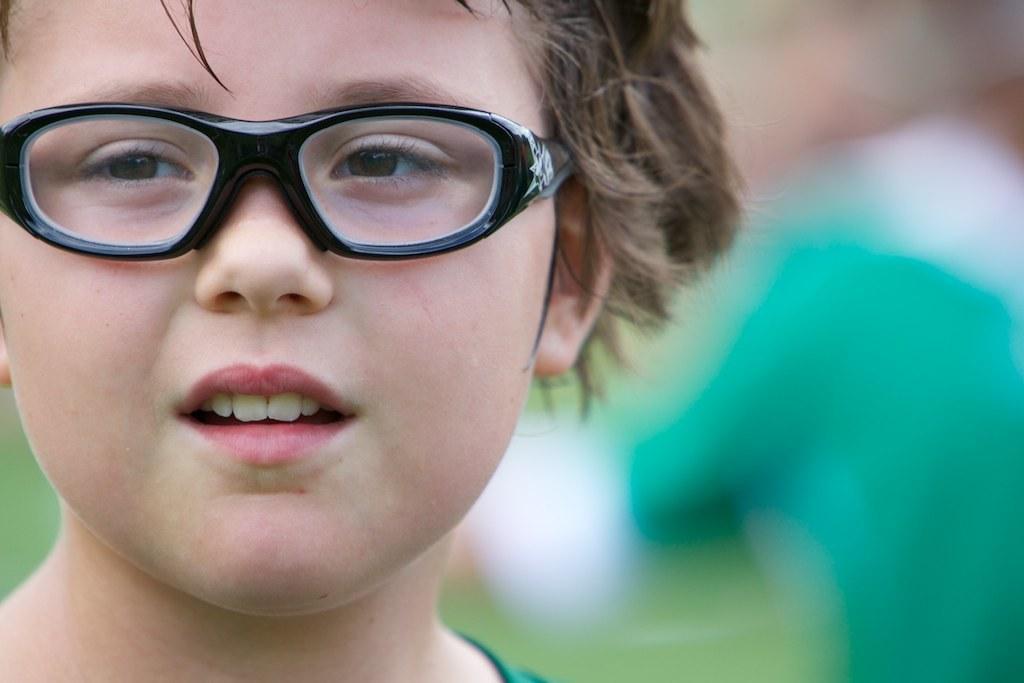Can you describe this image briefly? In this image I can see the person with the specs. I can see there is a blurred background. 